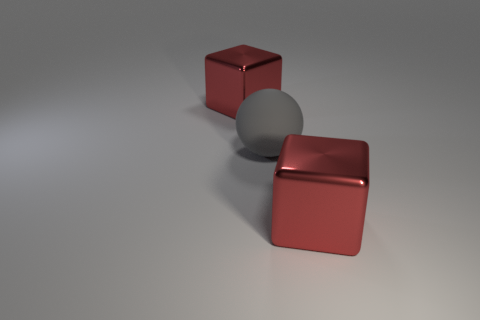Do the large metal thing that is behind the matte ball and the large metallic thing that is in front of the large sphere have the same shape?
Keep it short and to the point. Yes. What is the size of the gray sphere?
Offer a terse response. Large. What is the material of the red block that is on the left side of the red shiny thing right of the large red thing behind the large gray sphere?
Provide a short and direct response. Metal. How many red objects are big blocks or rubber things?
Provide a succinct answer. 2. There is a big red thing that is left of the rubber sphere; what is it made of?
Your answer should be compact. Metal. Do the red object left of the large rubber sphere and the gray thing have the same material?
Offer a terse response. No. What is the shape of the large gray rubber thing?
Your answer should be very brief. Sphere. What number of red metal things are behind the gray sphere to the left of the big metal block that is in front of the gray rubber sphere?
Your answer should be very brief. 1. What number of other objects are the same material as the large ball?
Ensure brevity in your answer.  0. Is the color of the big thing to the right of the sphere the same as the big cube behind the big gray thing?
Keep it short and to the point. Yes. 